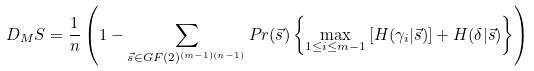Convert formula to latex. <formula><loc_0><loc_0><loc_500><loc_500>D _ { M } S = \frac { 1 } { n } \left ( 1 - \sum _ { \vec { s } \in G F ( 2 ) ^ { ( m - 1 ) ( n - 1 ) } } P r ( \vec { s } ) \left \{ \max _ { 1 \leq i \leq m - 1 } \left [ H ( \gamma _ { i } | \vec { s } ) \right ] + H ( \delta | \vec { s } ) \right \} \right )</formula> 